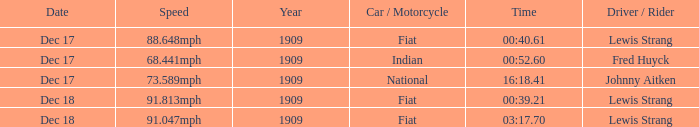Which driver is Indian? Fred Huyck. Can you parse all the data within this table? {'header': ['Date', 'Speed', 'Year', 'Car / Motorcycle', 'Time', 'Driver / Rider'], 'rows': [['Dec 17', '88.648mph', '1909', 'Fiat', '00:40.61', 'Lewis Strang'], ['Dec 17', '68.441mph', '1909', 'Indian', '00:52.60', 'Fred Huyck'], ['Dec 17', '73.589mph', '1909', 'National', '16:18.41', 'Johnny Aitken'], ['Dec 18', '91.813mph', '1909', 'Fiat', '00:39.21', 'Lewis Strang'], ['Dec 18', '91.047mph', '1909', 'Fiat', '03:17.70', 'Lewis Strang']]} 